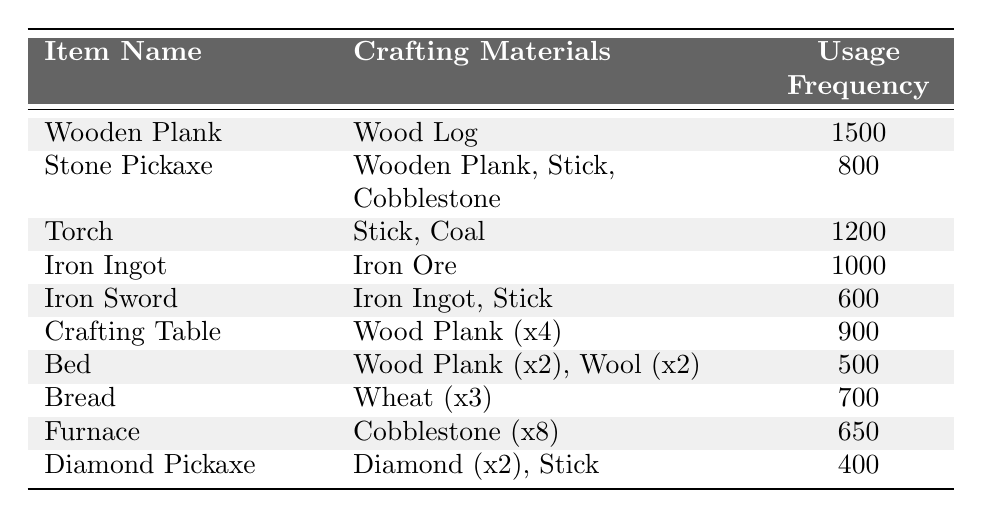What is the usage frequency of the Wooden Plank? The table lists the Wooden Plank with a usage frequency of 1500.
Answer: 1500 How many crafting materials are needed to make a Stone Pickaxe? The Stone Pickaxe requires 3 crafting materials: Wooden Plank, Stick, and Cobblestone.
Answer: 3 Which item has the highest usage frequency? By reviewing the usage frequencies, the Wooden Plank has the highest usage frequency of 1500.
Answer: Wooden Plank Is the Iron Sword crafted using any wooden materials? The Iron Sword requires an Iron Ingot and a Stick; the Stick is made from wood, so yes, it uses wood indirectly.
Answer: Yes What is the total usage frequency of all the items? To find the total, add the usage frequencies: 1500 + 800 + 1200 + 1000 + 600 + 900 + 500 + 700 + 650 + 400 = 6050.
Answer: 6050 Which item requires the most types of materials to craft? The Stone Pickaxe requires 3 different materials while the Crafting Table and others require fewer; thus, it has the most materials.
Answer: Stone Pickaxe What is the average usage frequency of the items listed? Sum all the usage frequencies (6050) and divide by the number of items (10), so 6050/10 = 605.
Answer: 605 Which item can be crafted using just one type of material? Both Iron Ingot and Wooden Plank can be crafted using just one material (Iron Ore and Wood Log, respectively).
Answer: Iron Ingot and Wooden Plank How many items have a usage frequency below 700? By checking the values, only the Bed, Furnace, and Diamond Pickaxe have usage frequencies below 700; that's 3 items.
Answer: 3 What is the difference between the highest and lowest usage frequencies? The highest frequency is 1500 (Wooden Plank) and the lowest is 400 (Diamond Pickaxe). Thus, the difference is 1500 - 400 = 1100.
Answer: 1100 